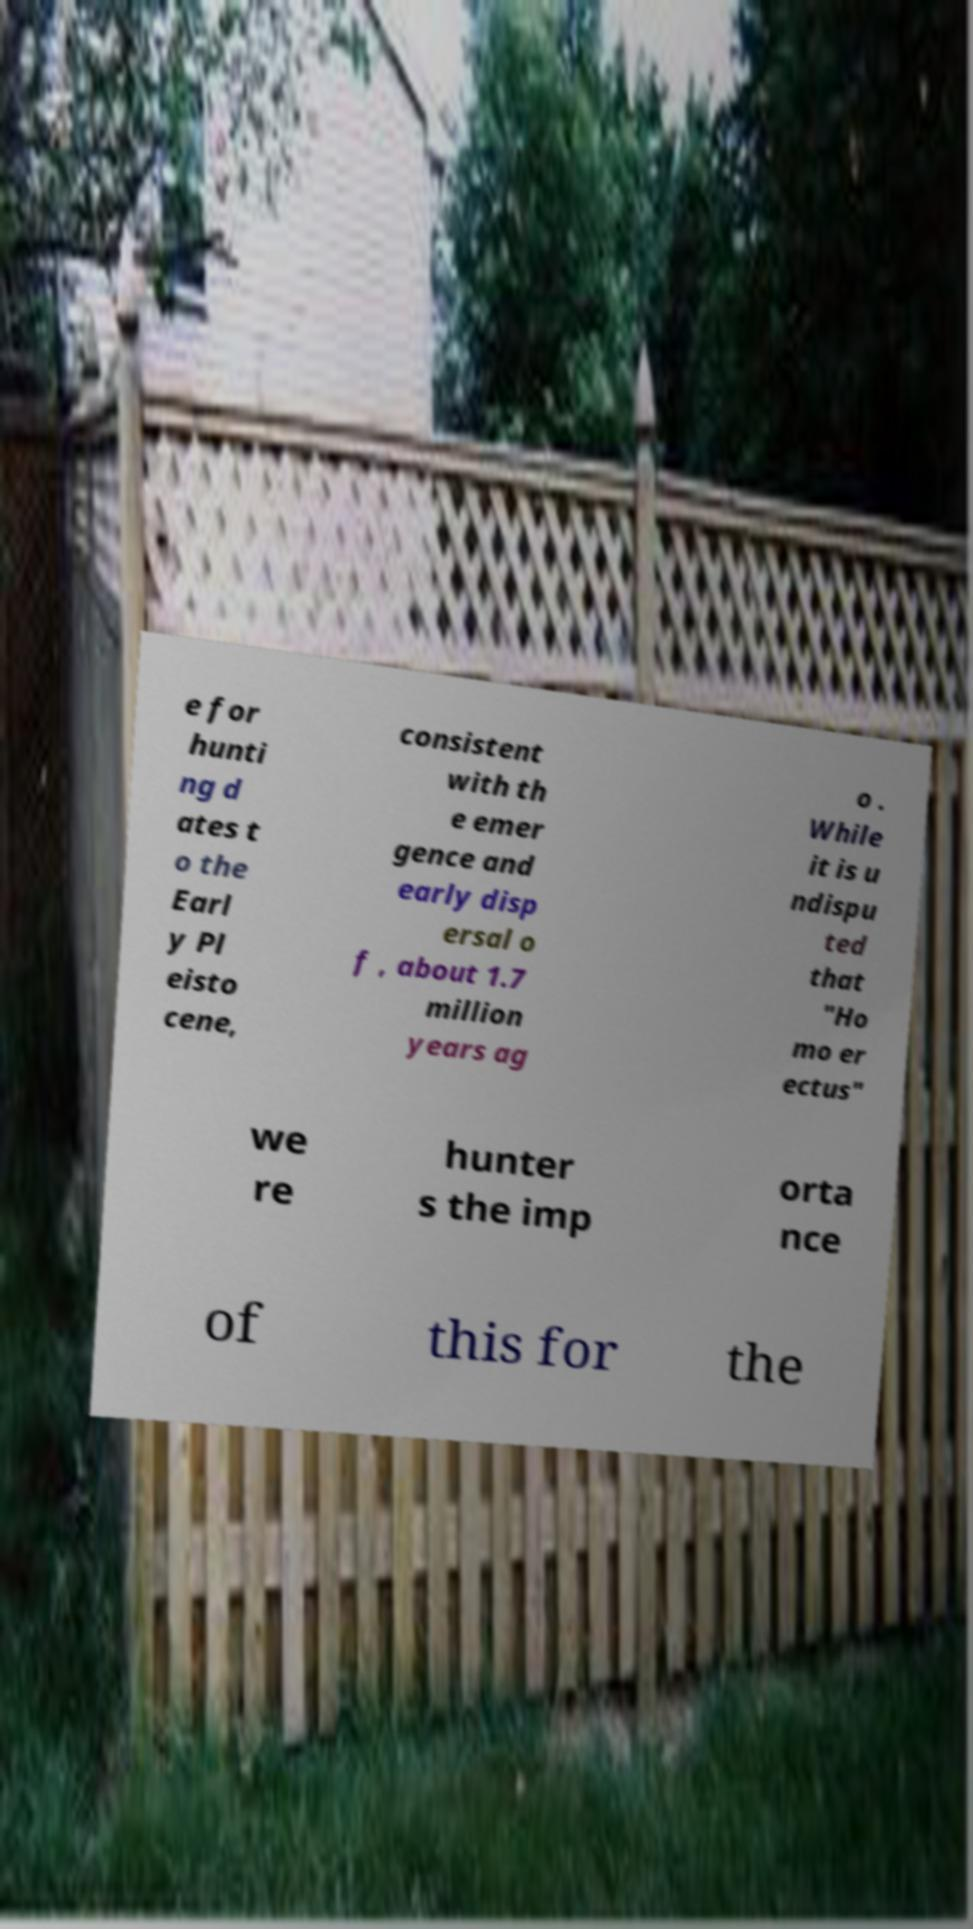What messages or text are displayed in this image? I need them in a readable, typed format. e for hunti ng d ates t o the Earl y Pl eisto cene, consistent with th e emer gence and early disp ersal o f , about 1.7 million years ag o . While it is u ndispu ted that "Ho mo er ectus" we re hunter s the imp orta nce of this for the 